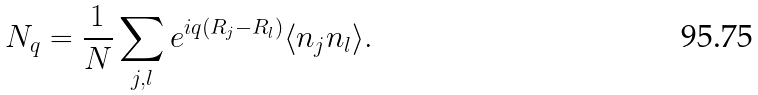<formula> <loc_0><loc_0><loc_500><loc_500>N _ { q } = \frac { 1 } { N } \sum _ { j , l } e ^ { i q ( R _ { j } - R _ { l } ) } \langle n _ { j } n _ { l } \rangle .</formula> 